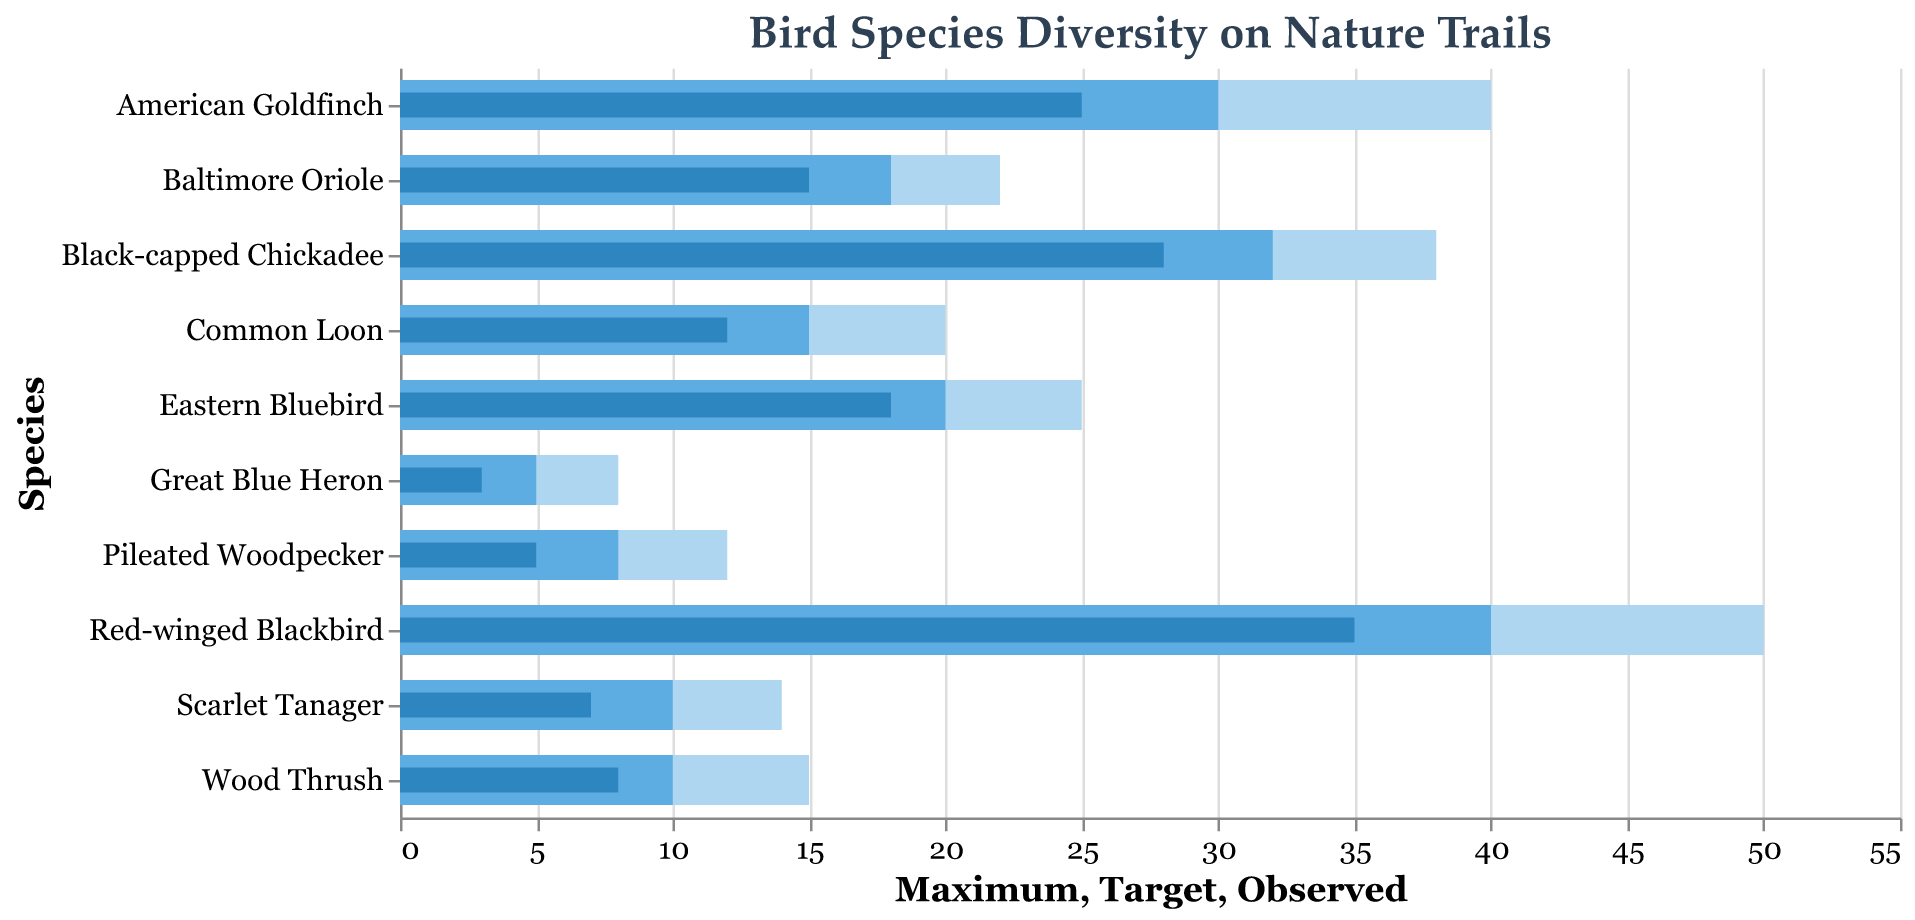What is the title of the figure? The title is displayed at the top of the chart, giving an overview of the chart's content.
Answer: Bird Species Diversity on Nature Trails How many species are listed in the chart? Count the number of unique species names listed along the y-axis.
Answer: 10 Which bird species has the highest observed number? Look at the "Observed" bars for each species and find the one with the highest value.
Answer: Red-winged Blackbird Which bird species has the lowest target number? Look at the "Target" bars for each species and find the one with the lowest value.
Answer: Great Blue Heron Which species' observed number is closest to its target? Find the species where the observed bar length is closest to the target bar length visually.
Answer: Eastern Bluebird Are there any species whose observed number exceeds their target number? Check if any "Observed" bars surpass the "Target" bars.
Answer: No For the Black-capped Chickadee, how much more is the maximum value compared to the target value? Subtract the target value from the maximum value for the Black-capped Chickadee.
Answer: 6 Which species has the largest gap between the observed and maximum values? For each species, subtract the "Observed" value from the "Maximum" value and determine which difference is largest.
Answer: Red-winged Blackbird What percentage of the target has the Pileated Woodpecker achieved? Divide Pileated Woodpecker's observed value by its target value and multiply by 100.
Answer: 62.5% Considering all species, how many have achieved at least half of their target? Calculate the number of species where observed values are at least 50% of their target values.
Answer: 7 What is the ratio of the observed to maximum value for the Baltimore Oriole? Divide the Baltimore Oriole's observed value by its maximum value.
Answer: ~0.68 How much does the observed value of the Common Loon fall short of the target? Subtract the observed value from the target value for the Common Loon.
Answer: 3 Among the species listed, how many exceeded their halfway mark towards their maximum value? Check if the observed value of each species is more than half of its maximum value.
Answer: 6 